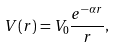Convert formula to latex. <formula><loc_0><loc_0><loc_500><loc_500>V ( { r } ) = V _ { 0 } \frac { e ^ { - \alpha r } } { r } ,</formula> 